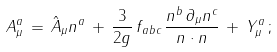Convert formula to latex. <formula><loc_0><loc_0><loc_500><loc_500>A ^ { a } _ { \mu } \, = \, \hat { A } _ { \mu } n ^ { a } \, + \, \frac { 3 } { 2 g } \, f _ { a b c } \, \frac { n ^ { b } \, \partial _ { \mu } n ^ { c } } { n \cdot n } \, + \, Y ^ { a } _ { \mu } \, ;</formula> 